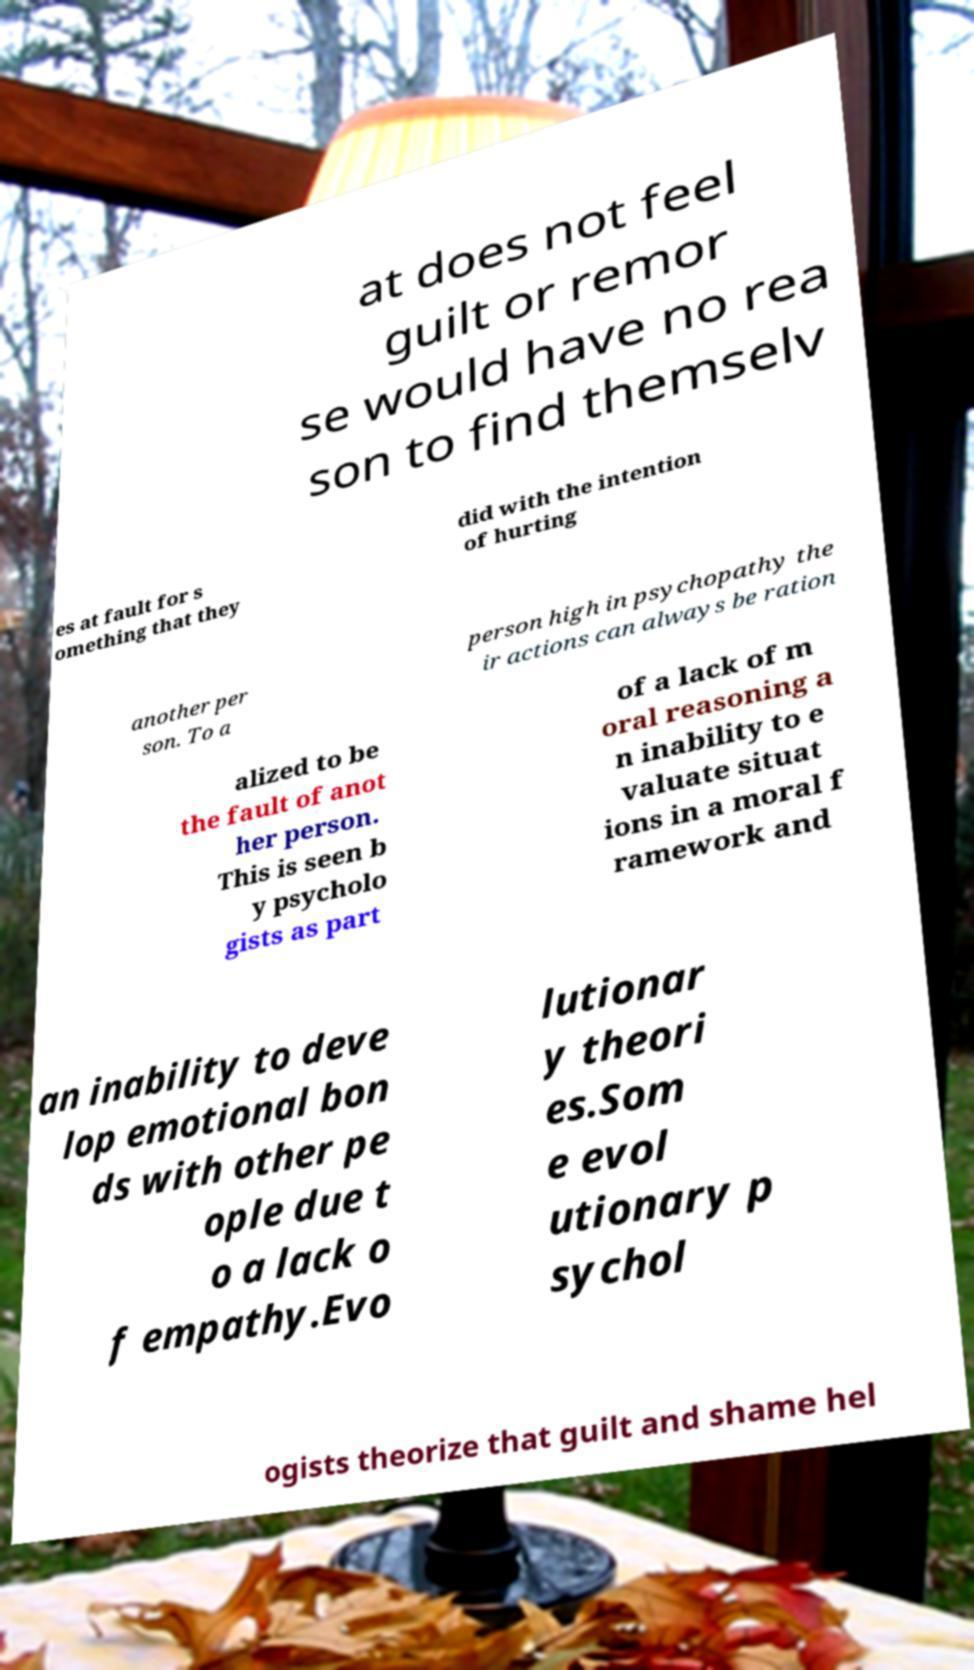For documentation purposes, I need the text within this image transcribed. Could you provide that? at does not feel guilt or remor se would have no rea son to find themselv es at fault for s omething that they did with the intention of hurting another per son. To a person high in psychopathy the ir actions can always be ration alized to be the fault of anot her person. This is seen b y psycholo gists as part of a lack of m oral reasoning a n inability to e valuate situat ions in a moral f ramework and an inability to deve lop emotional bon ds with other pe ople due t o a lack o f empathy.Evo lutionar y theori es.Som e evol utionary p sychol ogists theorize that guilt and shame hel 